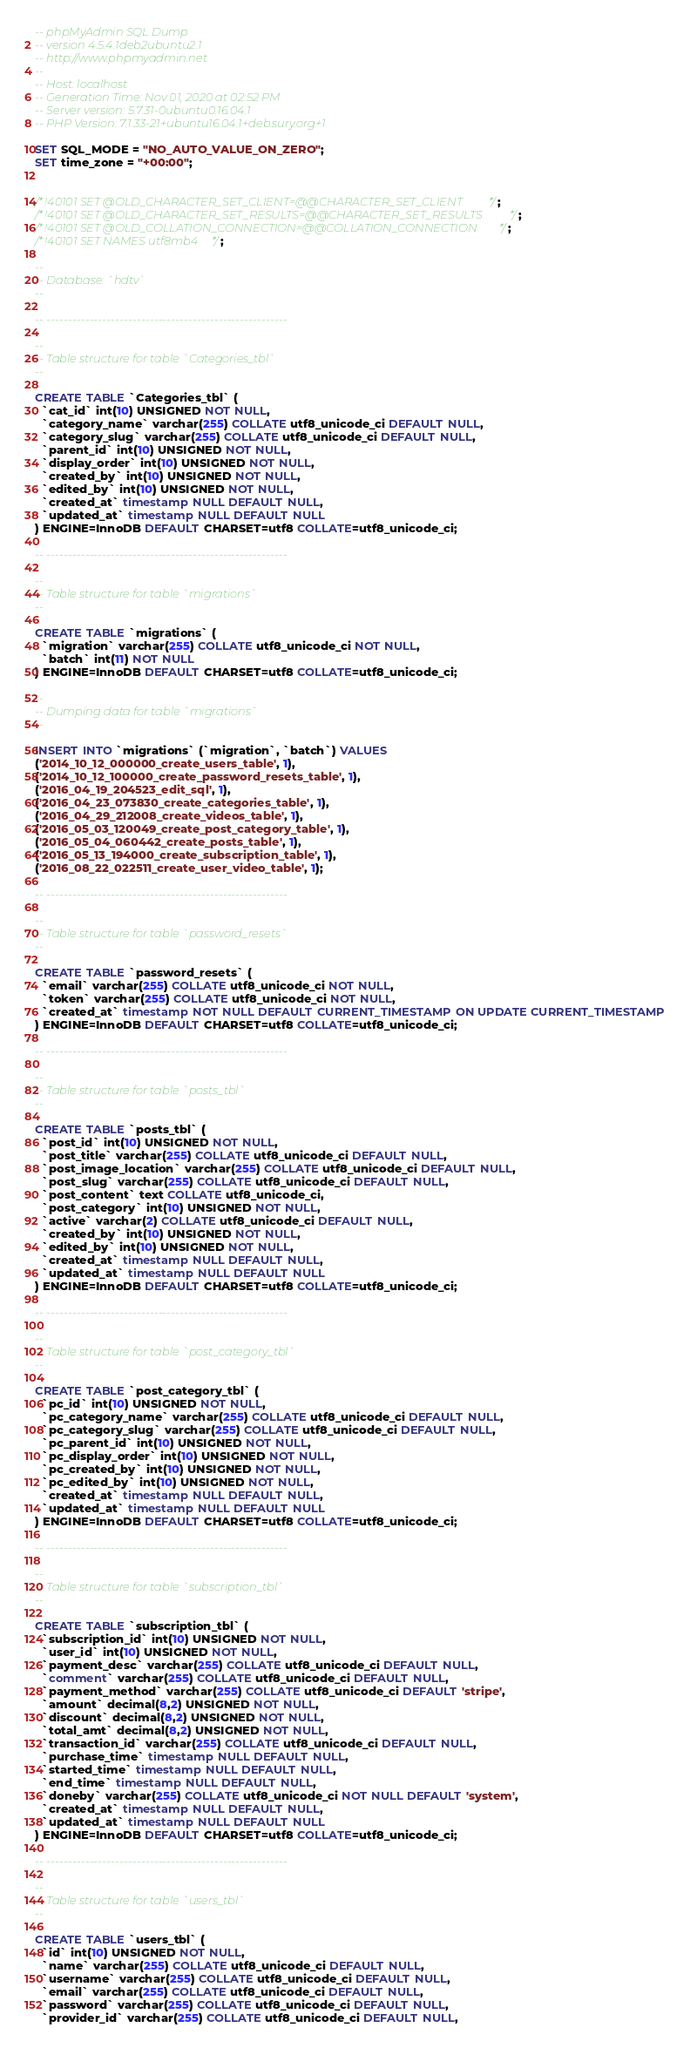Convert code to text. <code><loc_0><loc_0><loc_500><loc_500><_SQL_>-- phpMyAdmin SQL Dump
-- version 4.5.4.1deb2ubuntu2.1
-- http://www.phpmyadmin.net
--
-- Host: localhost
-- Generation Time: Nov 01, 2020 at 02:52 PM
-- Server version: 5.7.31-0ubuntu0.16.04.1
-- PHP Version: 7.1.33-21+ubuntu16.04.1+deb.sury.org+1

SET SQL_MODE = "NO_AUTO_VALUE_ON_ZERO";
SET time_zone = "+00:00";


/*!40101 SET @OLD_CHARACTER_SET_CLIENT=@@CHARACTER_SET_CLIENT */;
/*!40101 SET @OLD_CHARACTER_SET_RESULTS=@@CHARACTER_SET_RESULTS */;
/*!40101 SET @OLD_COLLATION_CONNECTION=@@COLLATION_CONNECTION */;
/*!40101 SET NAMES utf8mb4 */;

--
-- Database: `hdtv`
--

-- --------------------------------------------------------

--
-- Table structure for table `Categories_tbl`
--

CREATE TABLE `Categories_tbl` (
  `cat_id` int(10) UNSIGNED NOT NULL,
  `category_name` varchar(255) COLLATE utf8_unicode_ci DEFAULT NULL,
  `category_slug` varchar(255) COLLATE utf8_unicode_ci DEFAULT NULL,
  `parent_id` int(10) UNSIGNED NOT NULL,
  `display_order` int(10) UNSIGNED NOT NULL,
  `created_by` int(10) UNSIGNED NOT NULL,
  `edited_by` int(10) UNSIGNED NOT NULL,
  `created_at` timestamp NULL DEFAULT NULL,
  `updated_at` timestamp NULL DEFAULT NULL
) ENGINE=InnoDB DEFAULT CHARSET=utf8 COLLATE=utf8_unicode_ci;

-- --------------------------------------------------------

--
-- Table structure for table `migrations`
--

CREATE TABLE `migrations` (
  `migration` varchar(255) COLLATE utf8_unicode_ci NOT NULL,
  `batch` int(11) NOT NULL
) ENGINE=InnoDB DEFAULT CHARSET=utf8 COLLATE=utf8_unicode_ci;

--
-- Dumping data for table `migrations`
--

INSERT INTO `migrations` (`migration`, `batch`) VALUES
('2014_10_12_000000_create_users_table', 1),
('2014_10_12_100000_create_password_resets_table', 1),
('2016_04_19_204523_edit_sql', 1),
('2016_04_23_073830_create_categories_table', 1),
('2016_04_29_212008_create_videos_table', 1),
('2016_05_03_120049_create_post_category_table', 1),
('2016_05_04_060442_create_posts_table', 1),
('2016_05_13_194000_create_subscription_table', 1),
('2016_08_22_022511_create_user_video_table', 1);

-- --------------------------------------------------------

--
-- Table structure for table `password_resets`
--

CREATE TABLE `password_resets` (
  `email` varchar(255) COLLATE utf8_unicode_ci NOT NULL,
  `token` varchar(255) COLLATE utf8_unicode_ci NOT NULL,
  `created_at` timestamp NOT NULL DEFAULT CURRENT_TIMESTAMP ON UPDATE CURRENT_TIMESTAMP
) ENGINE=InnoDB DEFAULT CHARSET=utf8 COLLATE=utf8_unicode_ci;

-- --------------------------------------------------------

--
-- Table structure for table `posts_tbl`
--

CREATE TABLE `posts_tbl` (
  `post_id` int(10) UNSIGNED NOT NULL,
  `post_title` varchar(255) COLLATE utf8_unicode_ci DEFAULT NULL,
  `post_image_location` varchar(255) COLLATE utf8_unicode_ci DEFAULT NULL,
  `post_slug` varchar(255) COLLATE utf8_unicode_ci DEFAULT NULL,
  `post_content` text COLLATE utf8_unicode_ci,
  `post_category` int(10) UNSIGNED NOT NULL,
  `active` varchar(2) COLLATE utf8_unicode_ci DEFAULT NULL,
  `created_by` int(10) UNSIGNED NOT NULL,
  `edited_by` int(10) UNSIGNED NOT NULL,
  `created_at` timestamp NULL DEFAULT NULL,
  `updated_at` timestamp NULL DEFAULT NULL
) ENGINE=InnoDB DEFAULT CHARSET=utf8 COLLATE=utf8_unicode_ci;

-- --------------------------------------------------------

--
-- Table structure for table `post_category_tbl`
--

CREATE TABLE `post_category_tbl` (
  `pc_id` int(10) UNSIGNED NOT NULL,
  `pc_category_name` varchar(255) COLLATE utf8_unicode_ci DEFAULT NULL,
  `pc_category_slug` varchar(255) COLLATE utf8_unicode_ci DEFAULT NULL,
  `pc_parent_id` int(10) UNSIGNED NOT NULL,
  `pc_display_order` int(10) UNSIGNED NOT NULL,
  `pc_created_by` int(10) UNSIGNED NOT NULL,
  `pc_edited_by` int(10) UNSIGNED NOT NULL,
  `created_at` timestamp NULL DEFAULT NULL,
  `updated_at` timestamp NULL DEFAULT NULL
) ENGINE=InnoDB DEFAULT CHARSET=utf8 COLLATE=utf8_unicode_ci;

-- --------------------------------------------------------

--
-- Table structure for table `subscription_tbl`
--

CREATE TABLE `subscription_tbl` (
  `subscription_id` int(10) UNSIGNED NOT NULL,
  `user_id` int(10) UNSIGNED NOT NULL,
  `payment_desc` varchar(255) COLLATE utf8_unicode_ci DEFAULT NULL,
  `comment` varchar(255) COLLATE utf8_unicode_ci DEFAULT NULL,
  `payment_method` varchar(255) COLLATE utf8_unicode_ci DEFAULT 'stripe',
  `amount` decimal(8,2) UNSIGNED NOT NULL,
  `discount` decimal(8,2) UNSIGNED NOT NULL,
  `total_amt` decimal(8,2) UNSIGNED NOT NULL,
  `transaction_id` varchar(255) COLLATE utf8_unicode_ci DEFAULT NULL,
  `purchase_time` timestamp NULL DEFAULT NULL,
  `started_time` timestamp NULL DEFAULT NULL,
  `end_time` timestamp NULL DEFAULT NULL,
  `doneby` varchar(255) COLLATE utf8_unicode_ci NOT NULL DEFAULT 'system',
  `created_at` timestamp NULL DEFAULT NULL,
  `updated_at` timestamp NULL DEFAULT NULL
) ENGINE=InnoDB DEFAULT CHARSET=utf8 COLLATE=utf8_unicode_ci;

-- --------------------------------------------------------

--
-- Table structure for table `users_tbl`
--

CREATE TABLE `users_tbl` (
  `id` int(10) UNSIGNED NOT NULL,
  `name` varchar(255) COLLATE utf8_unicode_ci DEFAULT NULL,
  `username` varchar(255) COLLATE utf8_unicode_ci DEFAULT NULL,
  `email` varchar(255) COLLATE utf8_unicode_ci DEFAULT NULL,
  `password` varchar(255) COLLATE utf8_unicode_ci DEFAULT NULL,
  `provider_id` varchar(255) COLLATE utf8_unicode_ci DEFAULT NULL,</code> 